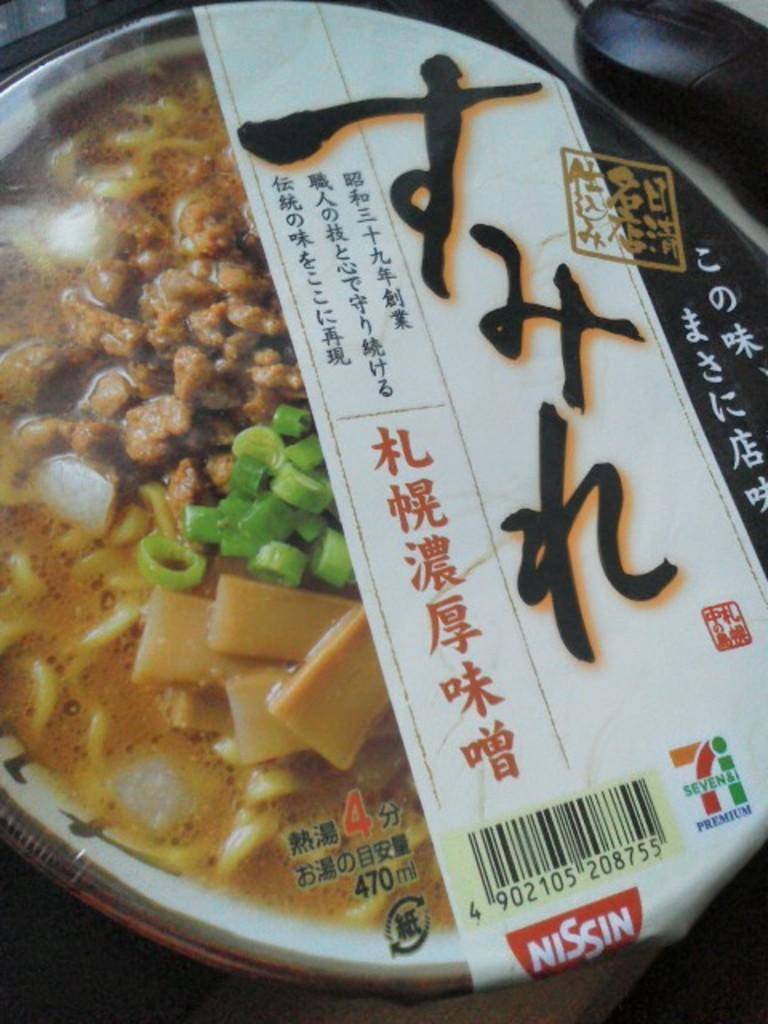What is in the bowl that is visible in the image? There are food items in a bowl in the image. What other object can be seen on the table in the image? There is a mouse on the table in the image. How many legs does the goldfish have in the image? There is no goldfish present in the image. Is there a bike visible in the image? No, there is no bike visible in the image. 